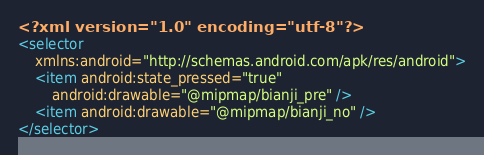<code> <loc_0><loc_0><loc_500><loc_500><_XML_><?xml version="1.0" encoding="utf-8"?>
<selector
    xmlns:android="http://schemas.android.com/apk/res/android">
    <item android:state_pressed="true"
        android:drawable="@mipmap/bianji_pre" />
    <item android:drawable="@mipmap/bianji_no" />
</selector></code> 